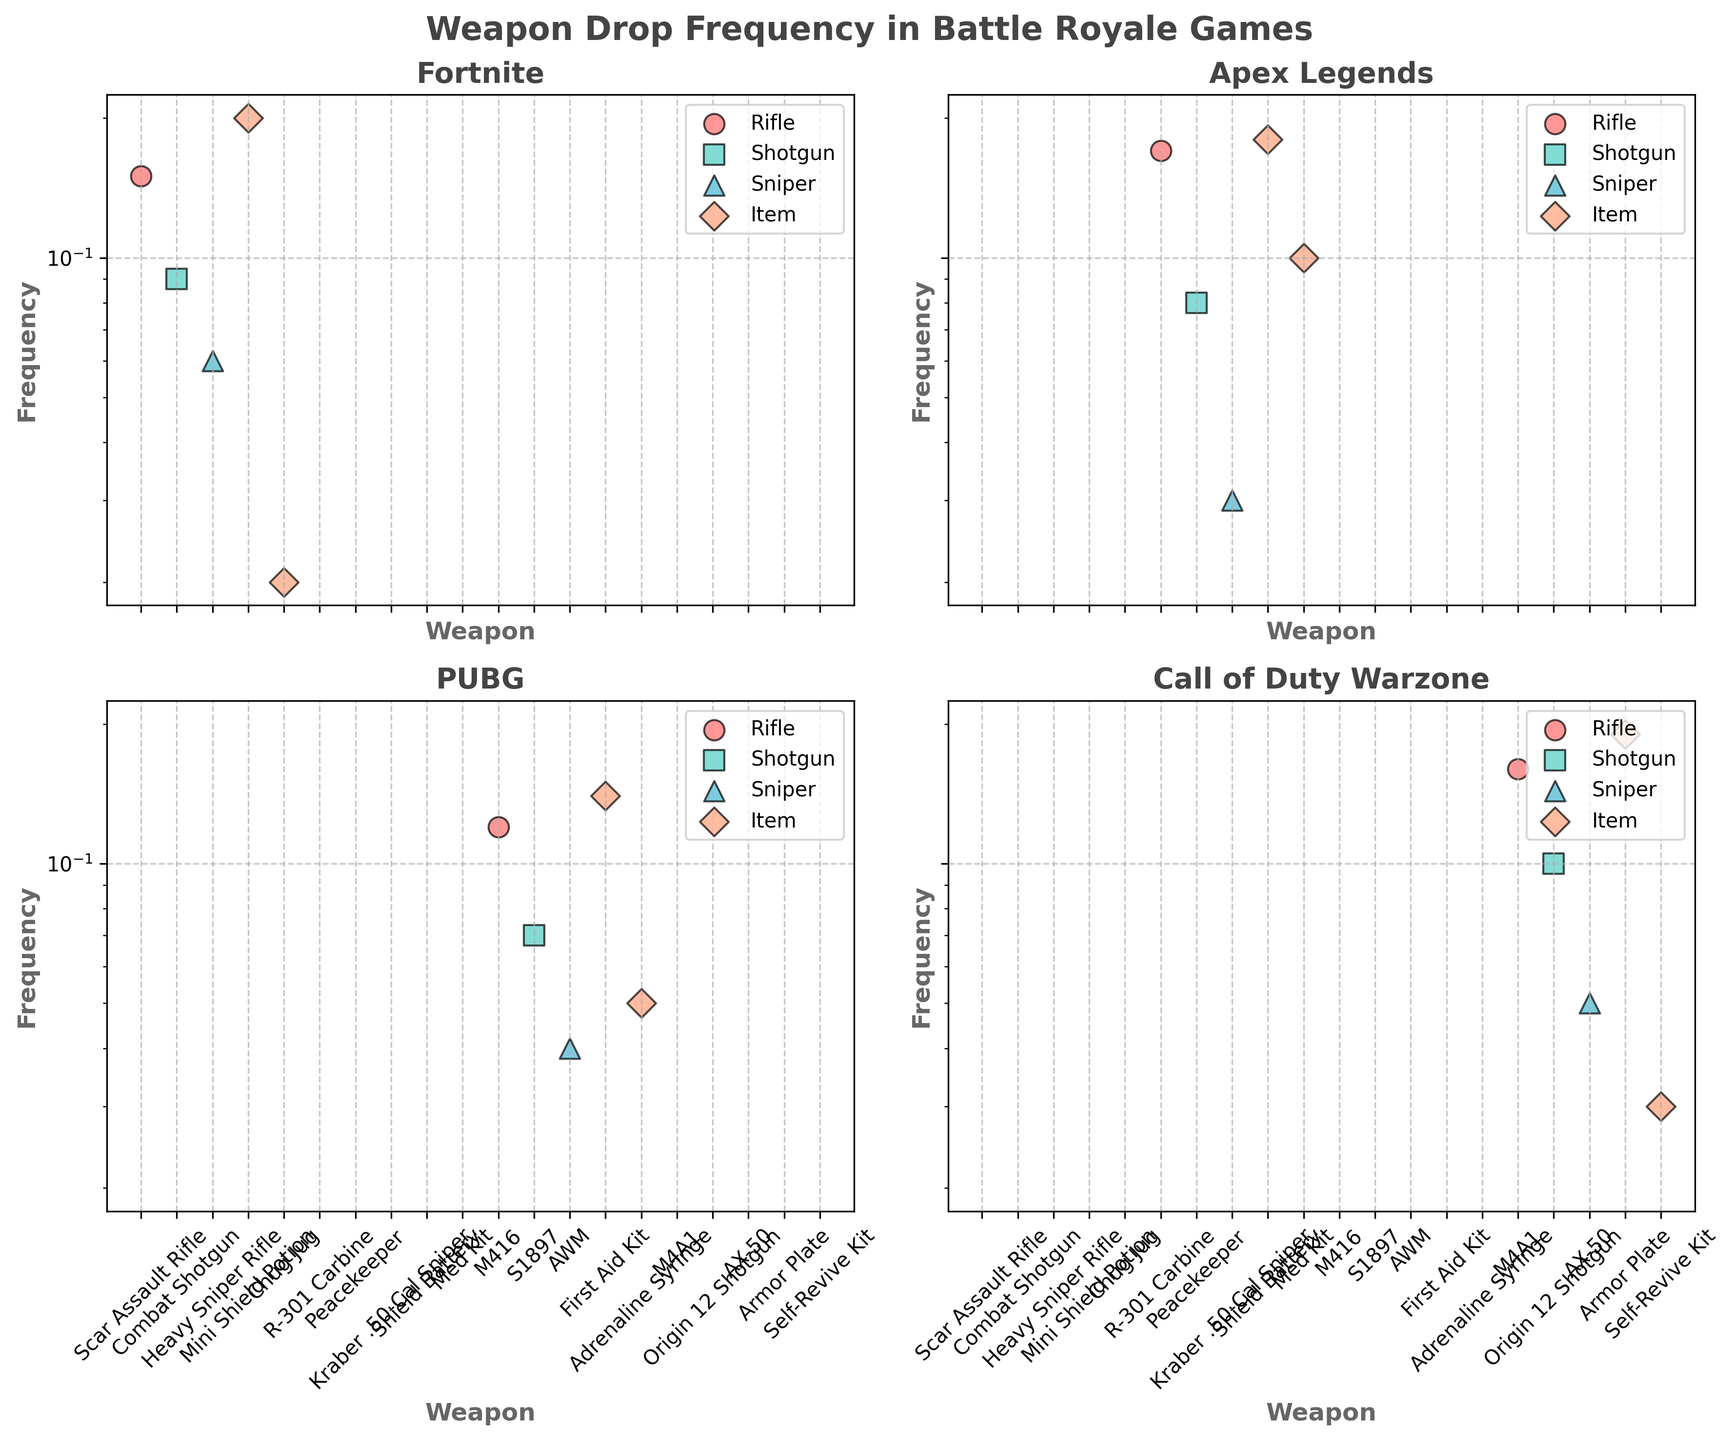What is the title of the figure? The title is located at the top of the plot and is usually formatted in a larger and bold font for emphasis. In this figure, the title is "Weapon Drop Frequency in Battle Royale Games".
Answer: Weapon Drop Frequency in Battle Royale Games How many weapons from "Fortnite" have a log scale frequency below 0.05? Refer to the subplot titled "Fortnite" and count the weapons located below the 0.05 line on the y-axis. In this case, only the "Chug Jug" weapon falls below this threshold.
Answer: 1 Which game has the weapon with the highest frequency? Look at the subplots and note the highest y-axis value for each game. Fortnite has a "Mini Shield Potion" with a frequency of 0.20, which is higher than any other weapon frequency in the other games.
Answer: Fortnite Which game's shotgun has the highest frequency? Compare the shotgun frequencies in each subplot. In "Call of Duty Warzone", the "Origin 12 Shotgun" has a frequency of 0.10, which is higher than the shotgun frequencies in the other games.
Answer: Call of Duty Warzone What are the rifle weapon frequencies in "Apex Legends"? Locate the subplot for "Apex Legends" and identify rifle frequencies, where "R-301 Carbine" falls under the rifle category, and its frequency is 0.17.
Answer: 0.17 How does the frequency of "Med Kit" in "Apex Legends" compare to "Adrenaline Syringe" in "PUBG"? Find the "Med Kit" in the "Apex Legends" subplot with a frequency of 0.10 and compare it to the "Adrenaline Syringe" in the "PUBG" subplot with a frequency of 0.05. The "Med Kit" has twice the frequency.
Answer: Med Kit has twice the frequency What is the average frequency of sniper category weapons in "PUBG"? Identify the sniper frequencies in the "PUBG" subplot, which are "AWM" at 0.04. Since there’s only one sniper, the average is 0.04 itself.
Answer: 0.04 Which game has the least frequent item category drop? Compare the smallest frequencies in the item category for each game. The "Chug Jug" from "Fortnite" has the lowest frequency at 0.02.
Answer: Fortnite Which weapon in "Call of Duty Warzone" has a frequency equal to "First Aid Kit" in "PUBG"? The "First Aid Kit" in "PUBG" has a frequency of 0.14. There is no weapon in "Call of Duty Warzone" with the same frequency, matching it is 0.14
Answer: None What's the color used to represent the "Item" category? The "Item" category is consistently represented by the same color in all subplots. In this figure, it is shown using the color in the legend, which is a shade of light blue or cyan.
Answer: Light blue/Cyan 